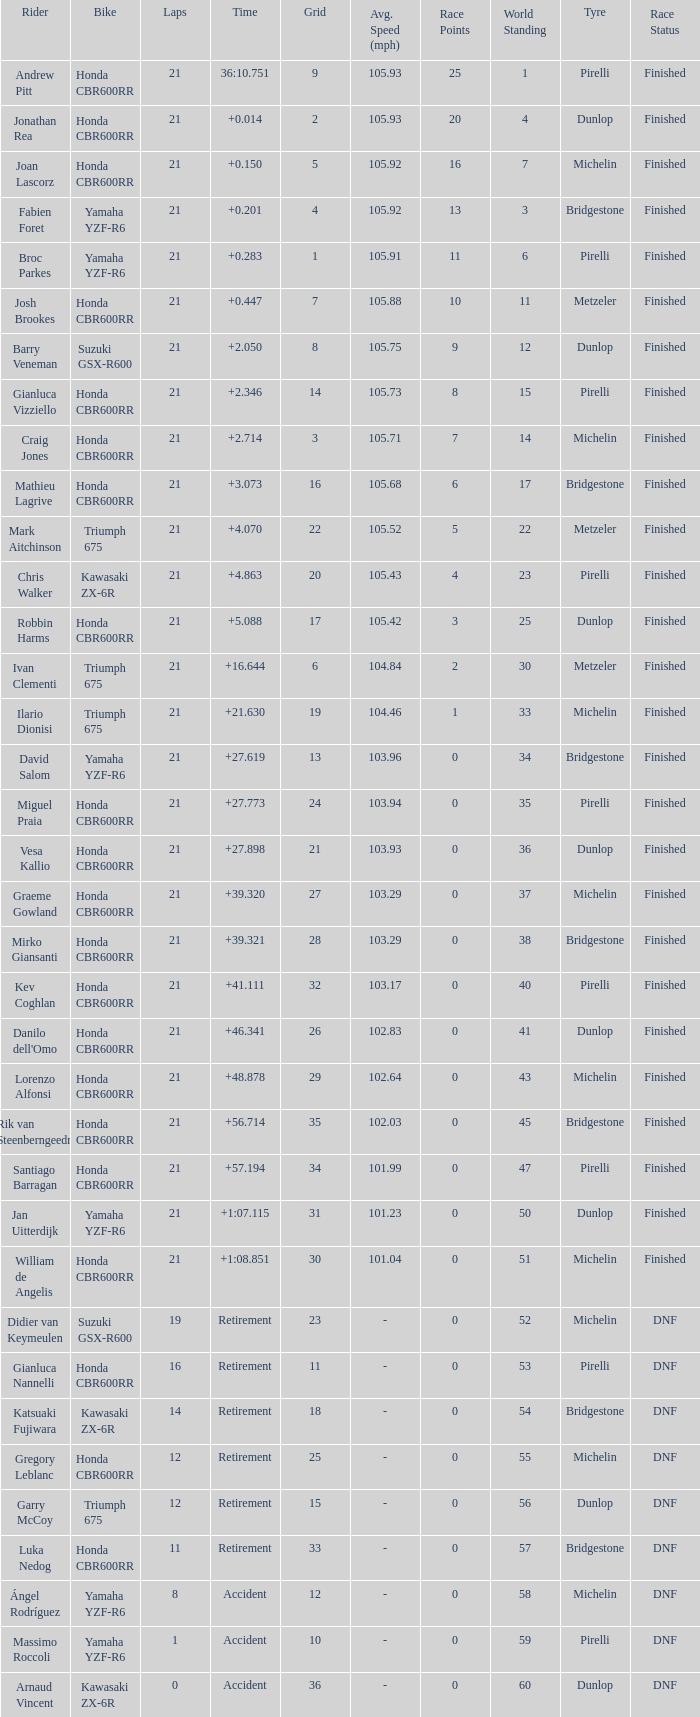What is the most number of laps run by Ilario Dionisi? 21.0. 